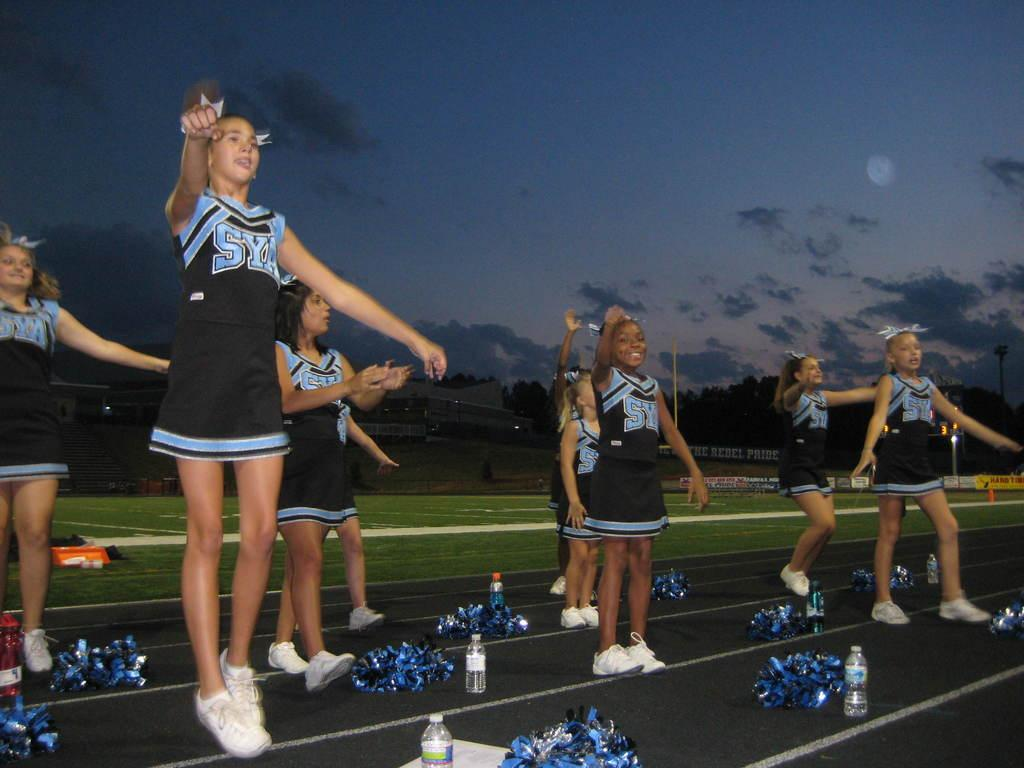<image>
Offer a succinct explanation of the picture presented. A group of cheerleaders from the school SYA. 